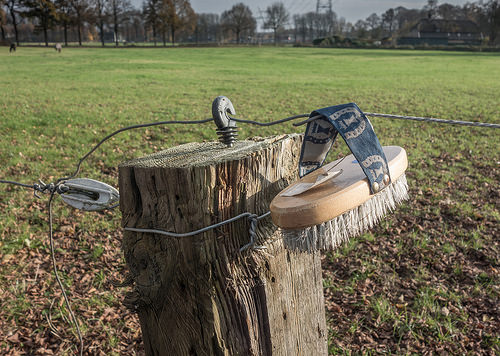<image>
Is the brush on the wire? Yes. Looking at the image, I can see the brush is positioned on top of the wire, with the wire providing support. Is there a wood on the grass? Yes. Looking at the image, I can see the wood is positioned on top of the grass, with the grass providing support. 